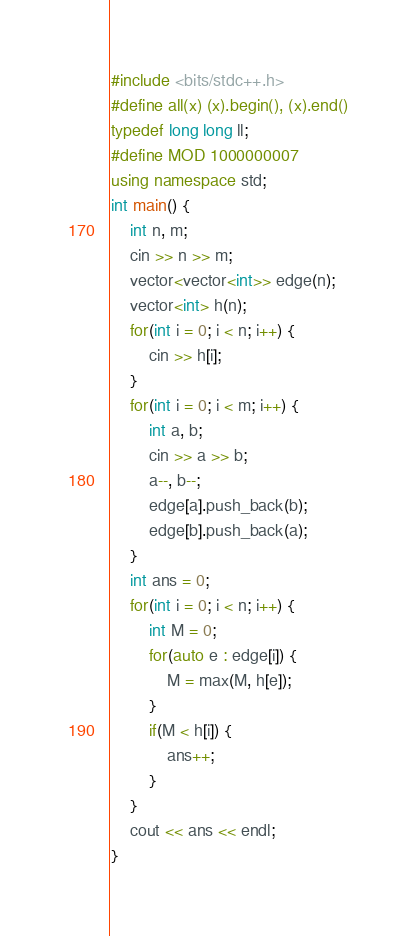<code> <loc_0><loc_0><loc_500><loc_500><_C++_>#include <bits/stdc++.h>
#define all(x) (x).begin(), (x).end()
typedef long long ll;
#define MOD 1000000007
using namespace std;
int main() {
    int n, m;
    cin >> n >> m;
    vector<vector<int>> edge(n);
    vector<int> h(n);
    for(int i = 0; i < n; i++) {
        cin >> h[i];
    }
    for(int i = 0; i < m; i++) {
        int a, b;
        cin >> a >> b;
        a--, b--;
        edge[a].push_back(b);
        edge[b].push_back(a);
    }
    int ans = 0;
    for(int i = 0; i < n; i++) {
        int M = 0;
        for(auto e : edge[i]) {
            M = max(M, h[e]);
        }
        if(M < h[i]) {
            ans++;
        }
    }
    cout << ans << endl;
}</code> 